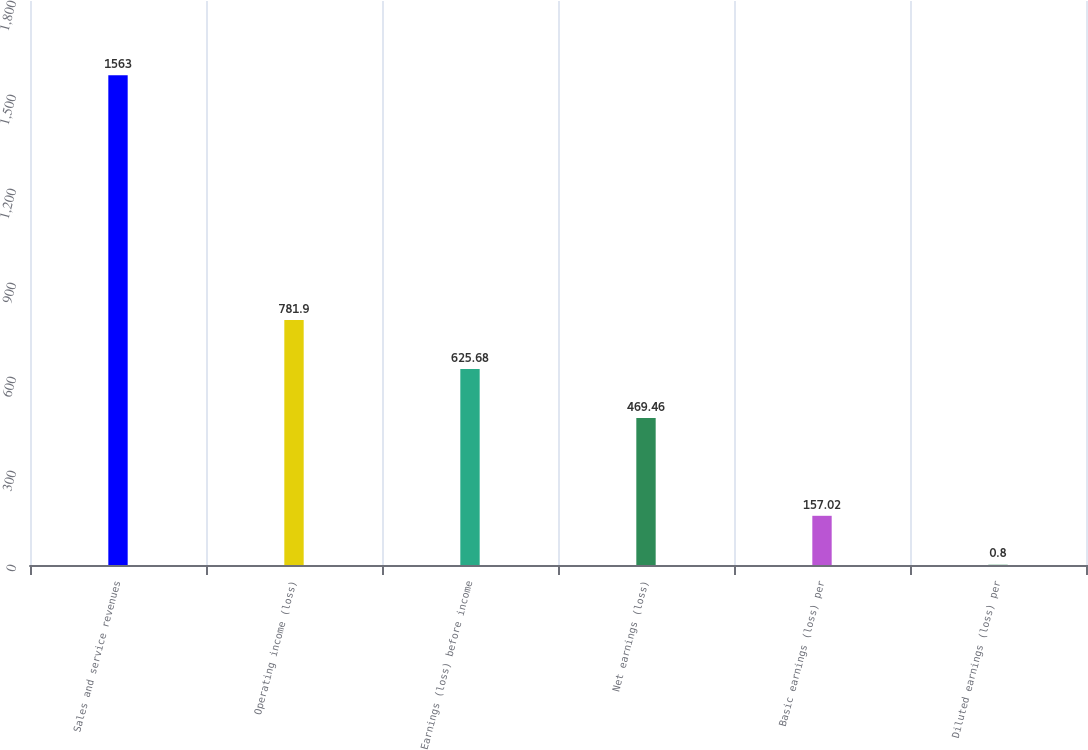Convert chart. <chart><loc_0><loc_0><loc_500><loc_500><bar_chart><fcel>Sales and service revenues<fcel>Operating income (loss)<fcel>Earnings (loss) before income<fcel>Net earnings (loss)<fcel>Basic earnings (loss) per<fcel>Diluted earnings (loss) per<nl><fcel>1563<fcel>781.9<fcel>625.68<fcel>469.46<fcel>157.02<fcel>0.8<nl></chart> 